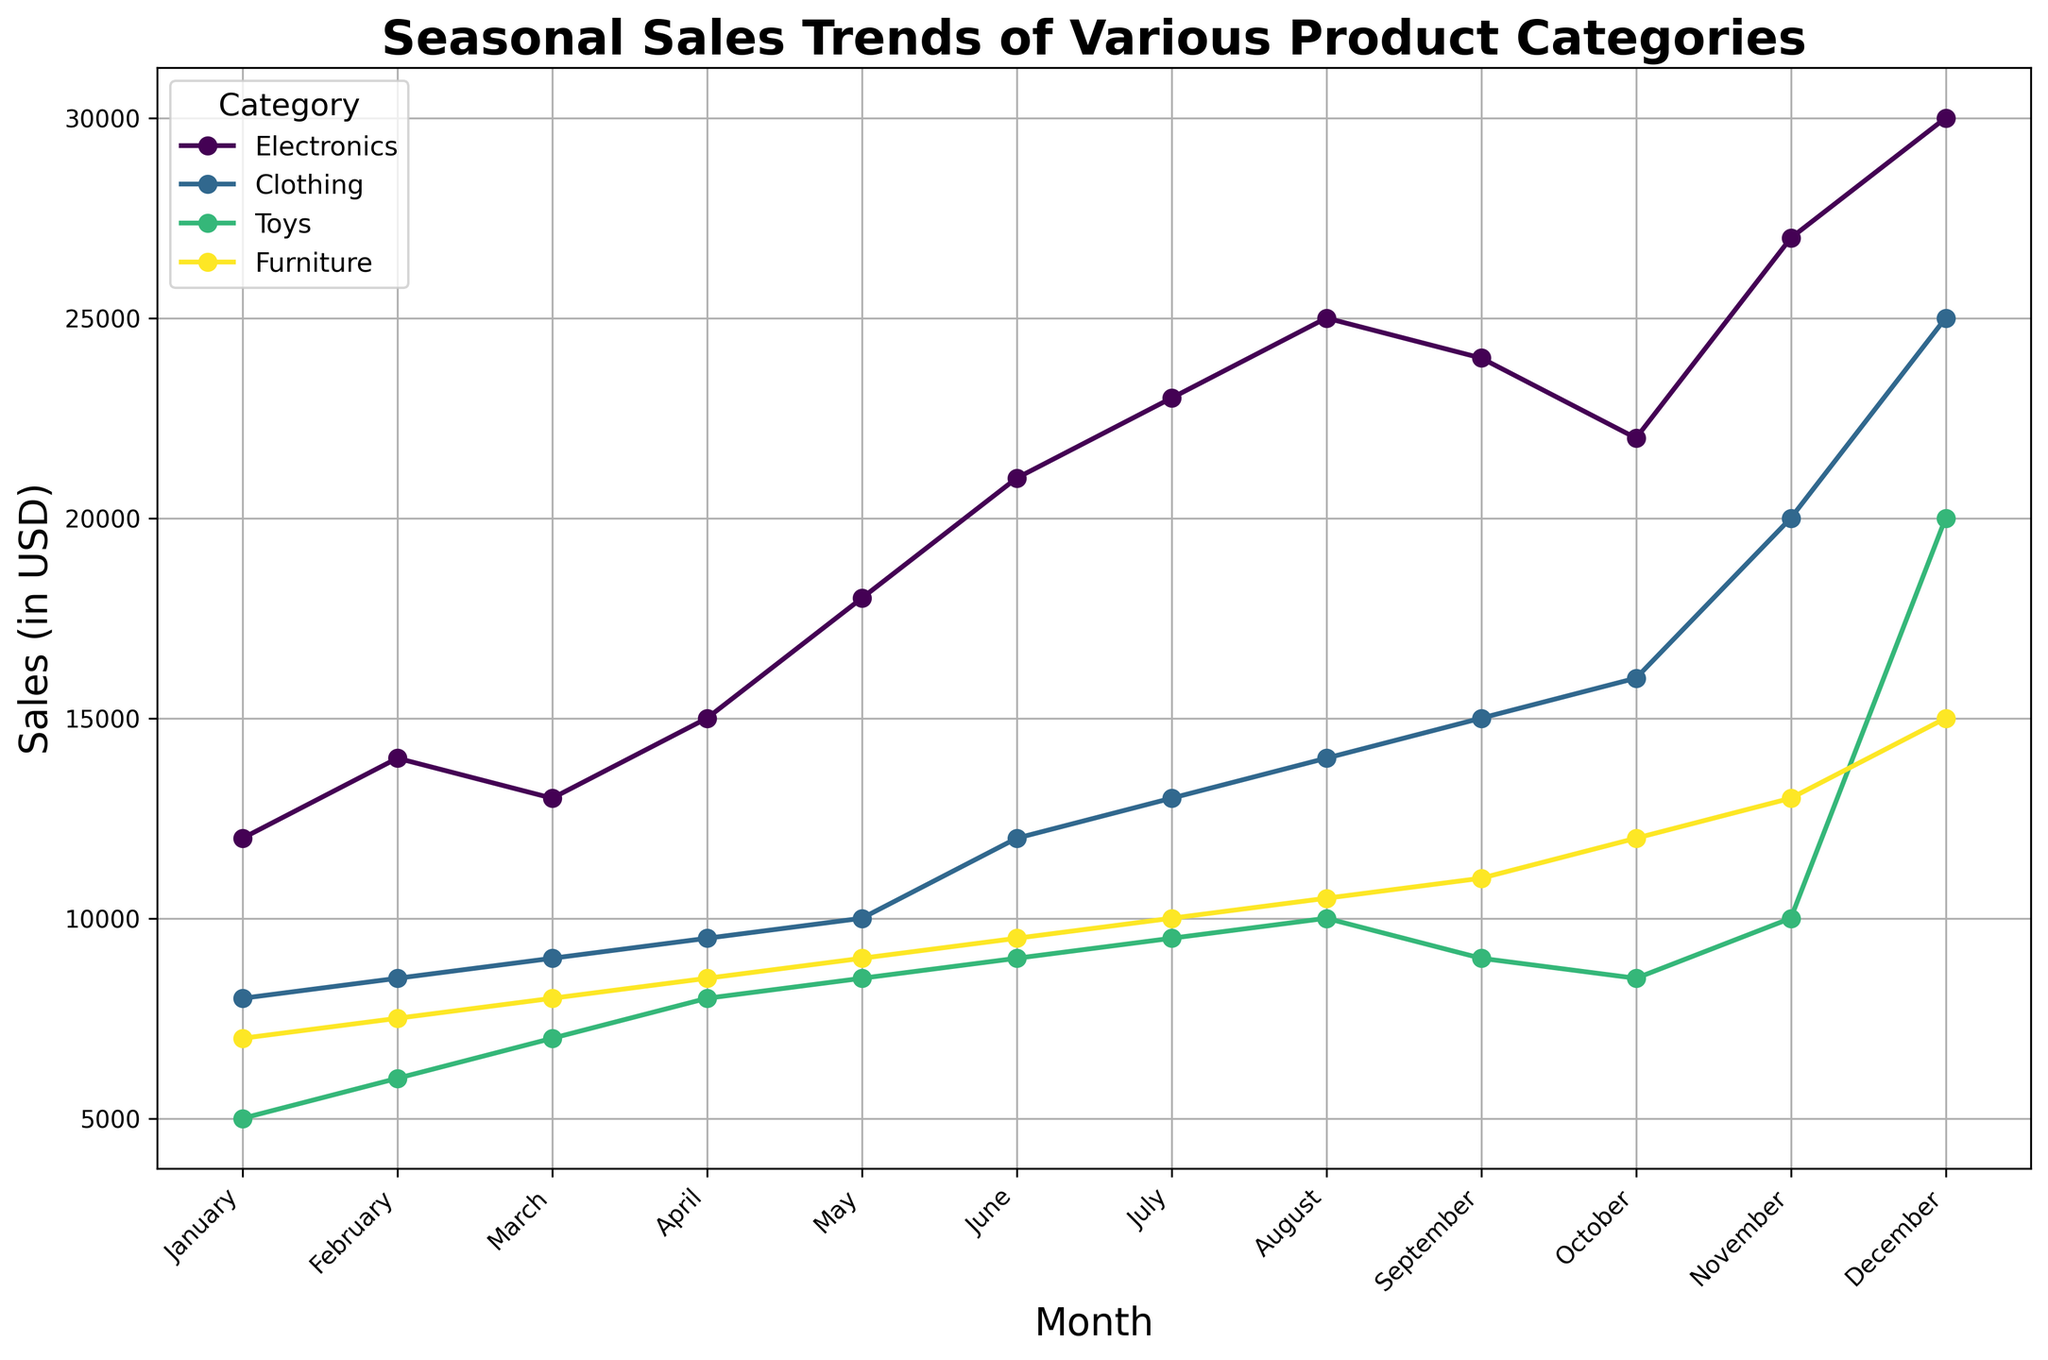Which category has the highest sales in December? Look at the data points for December for all categories and find the one with the highest y-value. Electronics has a sales value of 30000, which is the highest among the categories.
Answer: Electronics How does the sales trend for Clothing change from April to July? Observe the Clothing line from the data point for April to the data point for July. Clothing sales increase steadily from April (9500) to July (13000).
Answer: Increases steadily What is the difference in sales between Electronics and Toys in November? Find the sales value of Electronics and Toys in November and subtract Toys' value from Electronics'. Electronics: 27000, Toys: 10000, Difference: 27000 - 10000 = 17000.
Answer: 17000 Which two product categories show the largest increase in sales from September to November? Compare the sales values from September to November for all categories and determine the two with the largest increases. Clothing increases from 15000 to 20000 (5000 increase), and Electronics increases from 24000 to 27000 (3000 increase).
Answer: Clothing and Electronics What is the average sales value of Furniture from June to August? Sum the sales values for Furniture from June, July, and August and divide by 3. June: 9500, July: 10000, August: 10500, Average: (9500 + 10000 + 10500) / 3  = 10000.
Answer: 10000 Which category sees a significant spike in sales in December? Scan the sales values for December across all categories and identify any substantial increases. Toys jump from 10000 in November to 20000 in December, indicating a significant spike.
Answer: Toys What is the combined sales value of all categories in February? Sum up the sales values of all categories for the month of February. Electronics: 14000, Clothing: 8500, Toys: 6000, Furniture: 7500, Combined: 14000 + 8500 + 6000 + 7500 = 36000.
Answer: 36000 How do the sales trends of Electronics and Furniture compare from January to March? Compare the visual trend lines for Electronics and Furniture during the first quarter. Electronics shows an increasing trend (12000 to 13000), while Furniture also shows an increasing trend (7000 to 8000). Both increase, but Electronics remains higher throughout.
Answer: Both increase, Electronics higher What is the visual difference in the sales trends of Electronics and Toys in the month of August? Compare the height of the data points for Electronics and Toys in August. Electronics has a sales value of 25000, while Toys has a sales value of 10000. Electronics' point is significantly higher.
Answer: Electronics point higher What's the median value of Furniture sales across all months shown? List the sales values of Furniture for all months, order them, and find the median. Furniture sales: 7000, 7500, 8000, 8500, 9000, 9500, 10000, 10500, 11000, 12000, 13000, 15000; Median is the average of 6th and 7th values: (9500 + 10000) / 2 = 9750.
Answer: 9750 